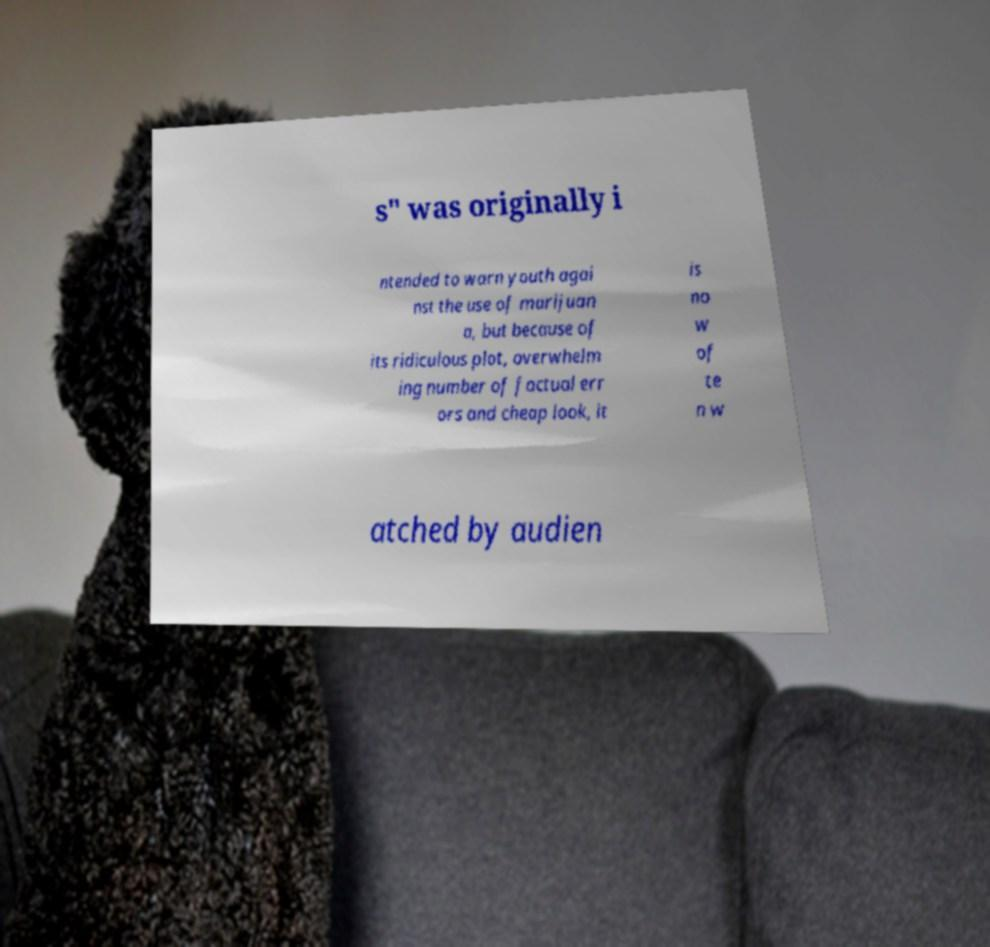Could you extract and type out the text from this image? s" was originally i ntended to warn youth agai nst the use of marijuan a, but because of its ridiculous plot, overwhelm ing number of factual err ors and cheap look, it is no w of te n w atched by audien 